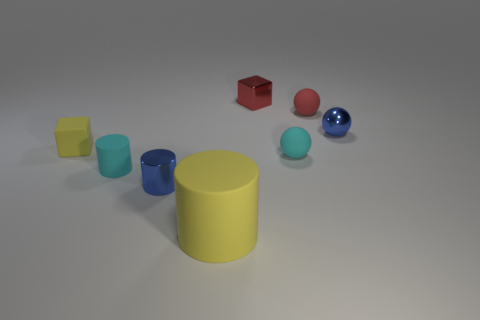Add 1 blue cylinders. How many objects exist? 9 Subtract all cylinders. How many objects are left? 5 Subtract 0 brown cubes. How many objects are left? 8 Subtract all metallic balls. Subtract all big things. How many objects are left? 6 Add 5 red matte spheres. How many red matte spheres are left? 6 Add 3 green objects. How many green objects exist? 3 